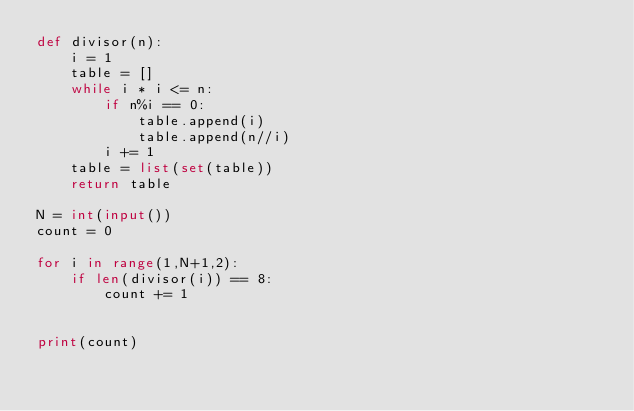<code> <loc_0><loc_0><loc_500><loc_500><_Python_>def divisor(n): 
    i = 1
    table = []
    while i * i <= n:
        if n%i == 0:
            table.append(i)
            table.append(n//i)
        i += 1
    table = list(set(table))
    return table

N = int(input())
count = 0

for i in range(1,N+1,2):
    if len(divisor(i)) == 8:
        count += 1


print(count)</code> 